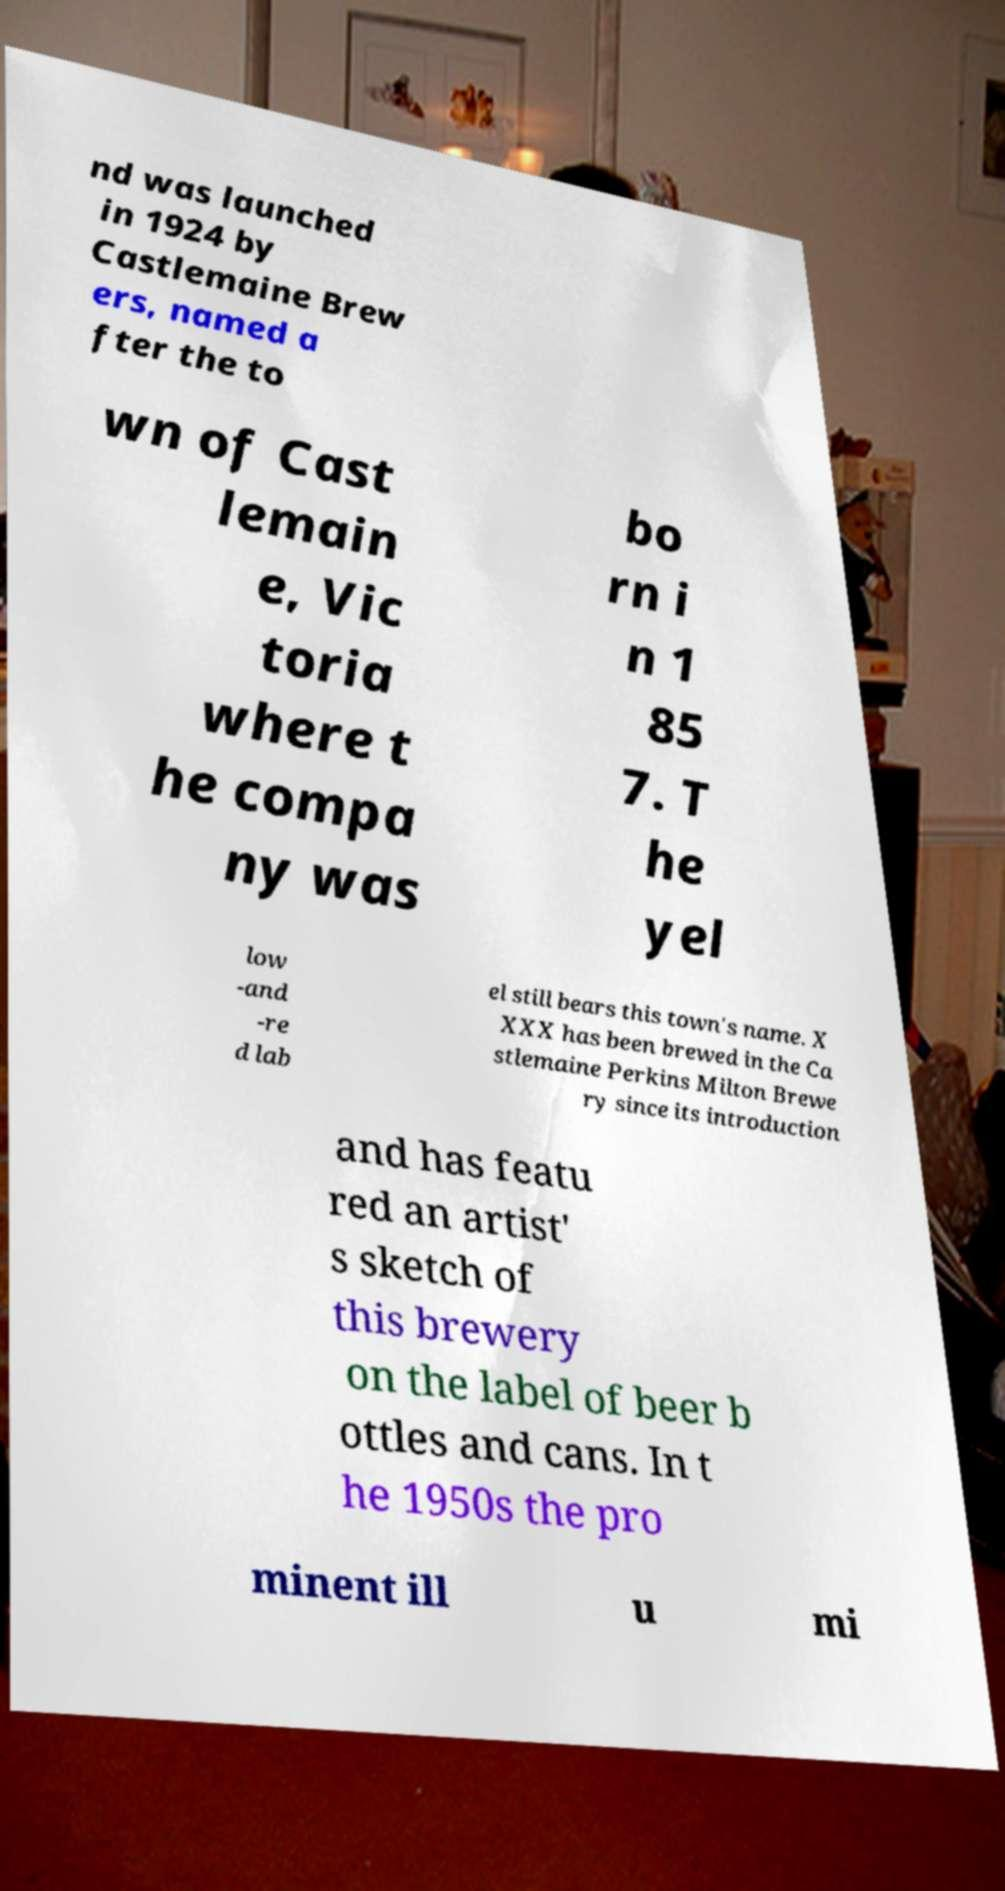Could you extract and type out the text from this image? nd was launched in 1924 by Castlemaine Brew ers, named a fter the to wn of Cast lemain e, Vic toria where t he compa ny was bo rn i n 1 85 7. T he yel low -and -re d lab el still bears this town's name. X XXX has been brewed in the Ca stlemaine Perkins Milton Brewe ry since its introduction and has featu red an artist' s sketch of this brewery on the label of beer b ottles and cans. In t he 1950s the pro minent ill u mi 